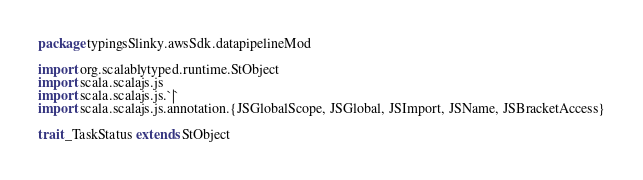Convert code to text. <code><loc_0><loc_0><loc_500><loc_500><_Scala_>package typingsSlinky.awsSdk.datapipelineMod

import org.scalablytyped.runtime.StObject
import scala.scalajs.js
import scala.scalajs.js.`|`
import scala.scalajs.js.annotation.{JSGlobalScope, JSGlobal, JSImport, JSName, JSBracketAccess}

trait _TaskStatus extends StObject
</code> 